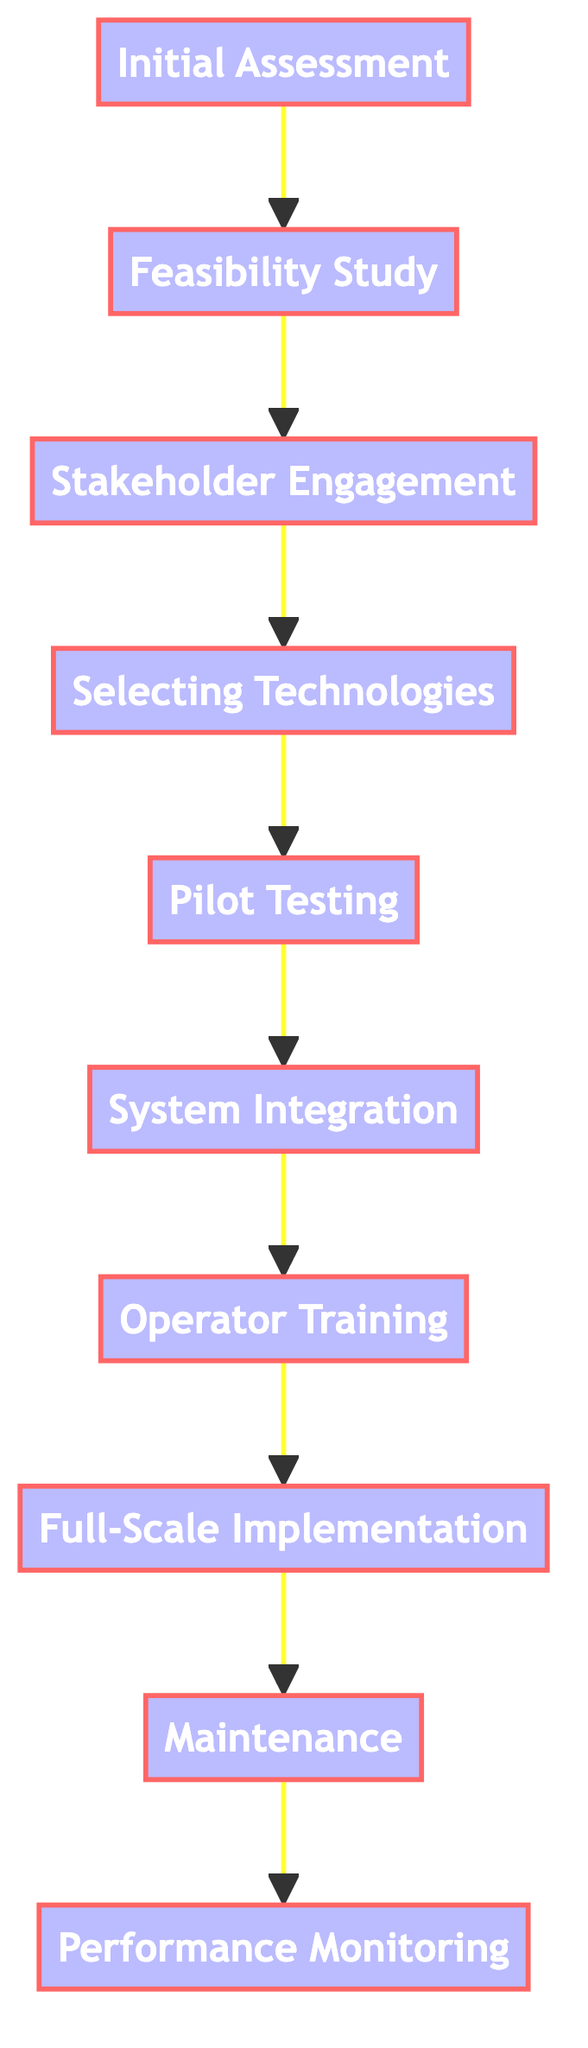What is the first step in the automation implementation process? The first step is indicated by the bottommost node in the flow chart, which is "Initial Assessment and Requirement Gathering."
Answer: Initial Assessment and Requirement Gathering How many steps are involved in the automation process? By counting the nodes from the flow chart, there are a total of 10 steps listed.
Answer: 10 What comes after the "Pilot Testing" stage? The flow chart shows that "System Integration" follows directly after "Pilot Testing."
Answer: System Integration Which node is directly before "Full-Scale Implementation"? Looking at the flow chart, "Operator Training" is the step that comes immediately before "Full-Scale Implementation."
Answer: Operator Training What are the last two steps in the process? The last two steps, as indicated at the top of the flow chart, are "Maintenance and Troubleshooting" and "Performance Monitoring and Optimization."
Answer: Maintenance and Troubleshooting, Performance Monitoring and Optimization Which step involves selecting technologies? In the flow chart, the step that involves selecting technologies is labeled "Selecting Automation Technologies."
Answer: Selecting Automation Technologies What is the purpose of the "Feasibility Study" step? The description adjacent to the "Feasibility Study" node states it is to "Conduct technical and economic feasibility study to determine the viability of automation."
Answer: Determine the viability of automation What is the primary focus of the "Stakeholder Engagement" step? This step focuses on engaging with various stakeholders to gather insights and support, as described next to "Stakeholder Engagement."
Answer: Gather insights and gain support How does the flow chart indicate the connection between "System Integration" and "Full-Scale Implementation"? The flow chart shows that "System Integration" feeds directly into "Operator Training," which subsequently connects to "Full-Scale Implementation," demonstrating a sequential relationship.
Answer: Sequential relationship Which phase directly involves operators and maintenance staff? The "Operator Training" phase is directly focused on providing training for operators and maintenance staff, as indicated by its description.
Answer: Operator Training 